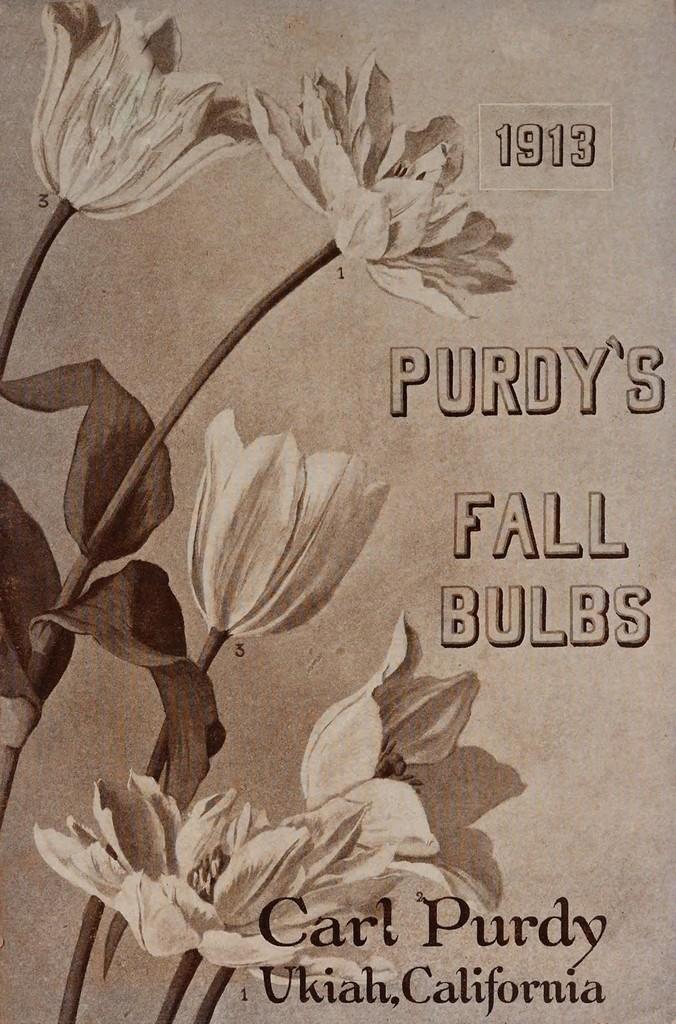In one or two sentences, can you explain what this image depicts? In this image we can see a card with flowers and some text on it. 